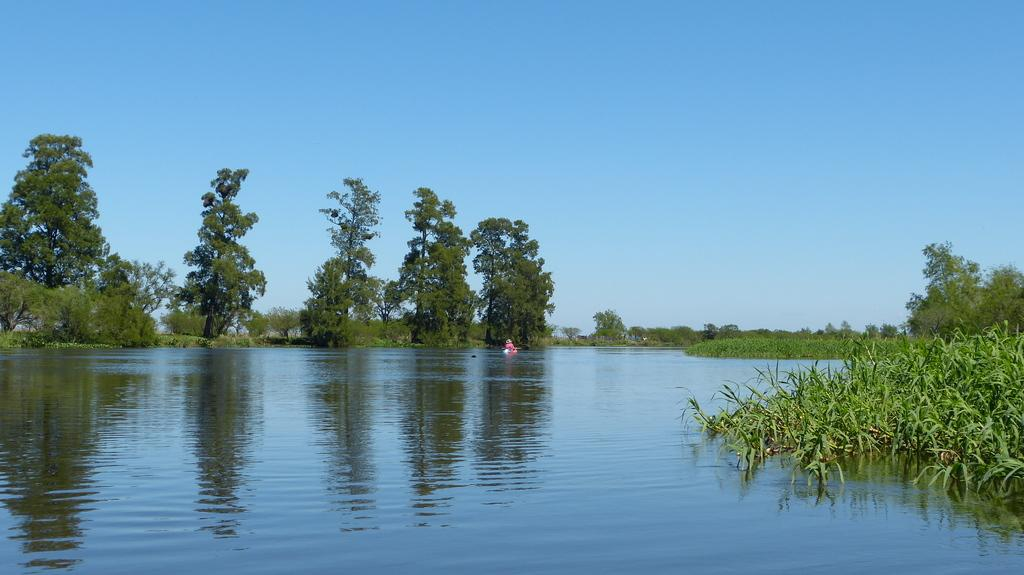What can be seen in the background of the image? The sky is visible in the background of the image. What type of vegetation is present in the image? There are trees and plants in the image. What natural element is visible in the image? Water is visible in the image. What is the color of the object in the image? There is a pink color object in the image. How many birds are sitting on the honeycomb in the image? There are no birds or honeycomb present in the image. What is the chance of winning a prize in the image? There is no indication of a prize or chance in the image. 